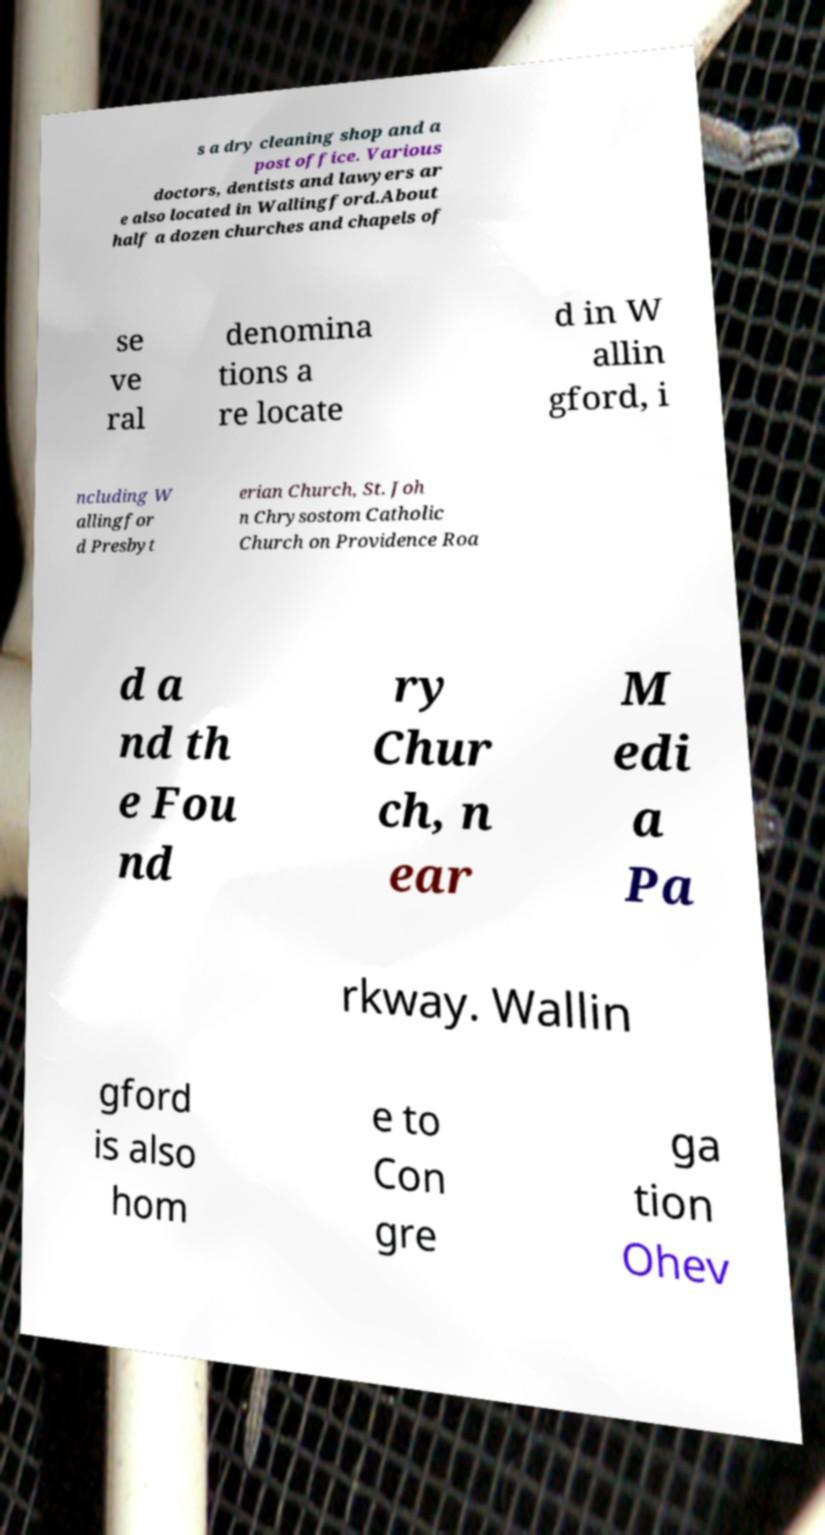Please read and relay the text visible in this image. What does it say? s a dry cleaning shop and a post office. Various doctors, dentists and lawyers ar e also located in Wallingford.About half a dozen churches and chapels of se ve ral denomina tions a re locate d in W allin gford, i ncluding W allingfor d Presbyt erian Church, St. Joh n Chrysostom Catholic Church on Providence Roa d a nd th e Fou nd ry Chur ch, n ear M edi a Pa rkway. Wallin gford is also hom e to Con gre ga tion Ohev 